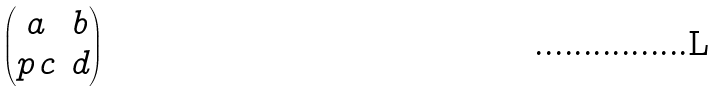Convert formula to latex. <formula><loc_0><loc_0><loc_500><loc_500>\begin{pmatrix} a & b \\ p \, c & d \end{pmatrix}</formula> 